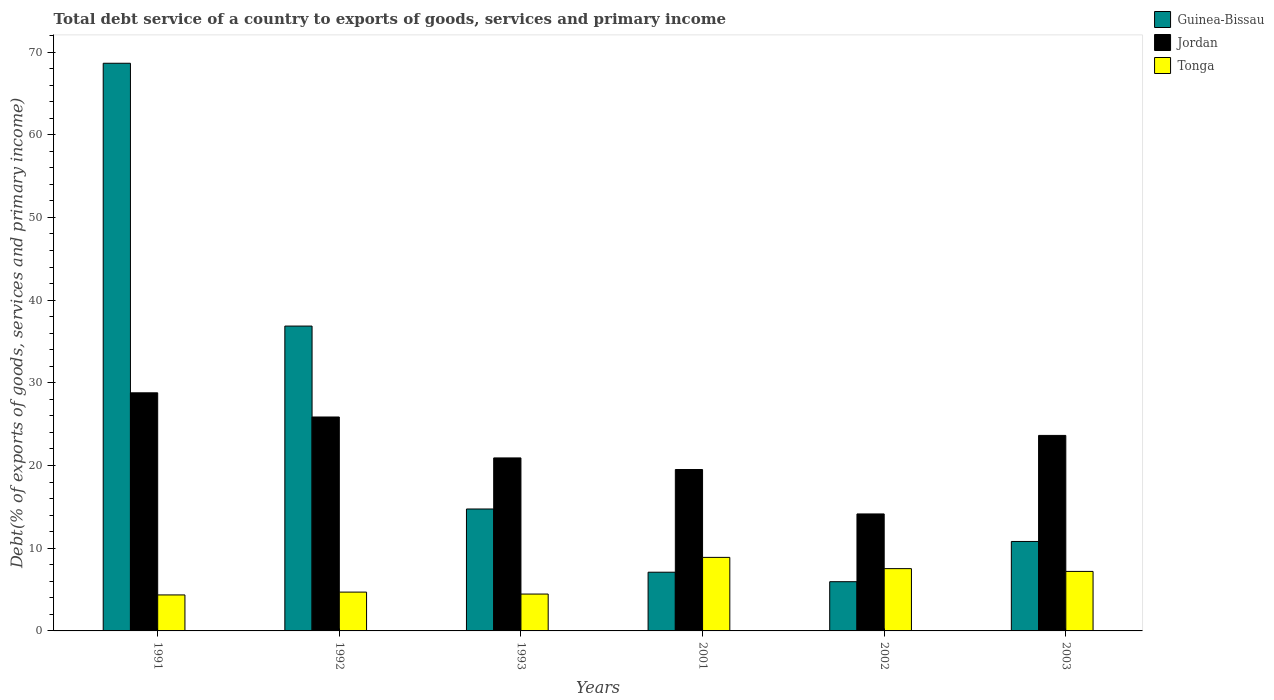Are the number of bars on each tick of the X-axis equal?
Make the answer very short. Yes. In how many cases, is the number of bars for a given year not equal to the number of legend labels?
Offer a terse response. 0. What is the total debt service in Tonga in 2001?
Offer a terse response. 8.89. Across all years, what is the maximum total debt service in Tonga?
Your response must be concise. 8.89. Across all years, what is the minimum total debt service in Guinea-Bissau?
Your answer should be very brief. 5.95. In which year was the total debt service in Guinea-Bissau minimum?
Your response must be concise. 2002. What is the total total debt service in Guinea-Bissau in the graph?
Give a very brief answer. 144.11. What is the difference between the total debt service in Tonga in 1991 and that in 2002?
Your response must be concise. -3.18. What is the difference between the total debt service in Tonga in 2003 and the total debt service in Jordan in 2002?
Your answer should be very brief. -6.95. What is the average total debt service in Jordan per year?
Give a very brief answer. 22.15. In the year 1993, what is the difference between the total debt service in Guinea-Bissau and total debt service in Tonga?
Make the answer very short. 10.28. In how many years, is the total debt service in Guinea-Bissau greater than 36 %?
Make the answer very short. 2. What is the ratio of the total debt service in Tonga in 1992 to that in 1993?
Give a very brief answer. 1.05. Is the total debt service in Tonga in 1993 less than that in 2002?
Give a very brief answer. Yes. What is the difference between the highest and the second highest total debt service in Guinea-Bissau?
Offer a very short reply. 31.78. What is the difference between the highest and the lowest total debt service in Tonga?
Your answer should be compact. 4.54. What does the 3rd bar from the left in 2001 represents?
Your answer should be very brief. Tonga. What does the 3rd bar from the right in 2001 represents?
Make the answer very short. Guinea-Bissau. How many bars are there?
Your answer should be compact. 18. How many years are there in the graph?
Make the answer very short. 6. Are the values on the major ticks of Y-axis written in scientific E-notation?
Provide a succinct answer. No. Does the graph contain any zero values?
Offer a terse response. No. Where does the legend appear in the graph?
Your answer should be very brief. Top right. How many legend labels are there?
Keep it short and to the point. 3. How are the legend labels stacked?
Offer a terse response. Vertical. What is the title of the graph?
Give a very brief answer. Total debt service of a country to exports of goods, services and primary income. What is the label or title of the Y-axis?
Your answer should be compact. Debt(% of exports of goods, services and primary income). What is the Debt(% of exports of goods, services and primary income) in Guinea-Bissau in 1991?
Keep it short and to the point. 68.64. What is the Debt(% of exports of goods, services and primary income) in Jordan in 1991?
Offer a terse response. 28.79. What is the Debt(% of exports of goods, services and primary income) of Tonga in 1991?
Keep it short and to the point. 4.35. What is the Debt(% of exports of goods, services and primary income) in Guinea-Bissau in 1992?
Give a very brief answer. 36.86. What is the Debt(% of exports of goods, services and primary income) in Jordan in 1992?
Ensure brevity in your answer.  25.87. What is the Debt(% of exports of goods, services and primary income) in Tonga in 1992?
Ensure brevity in your answer.  4.69. What is the Debt(% of exports of goods, services and primary income) in Guinea-Bissau in 1993?
Ensure brevity in your answer.  14.74. What is the Debt(% of exports of goods, services and primary income) of Jordan in 1993?
Give a very brief answer. 20.92. What is the Debt(% of exports of goods, services and primary income) in Tonga in 1993?
Give a very brief answer. 4.46. What is the Debt(% of exports of goods, services and primary income) of Guinea-Bissau in 2001?
Your answer should be compact. 7.1. What is the Debt(% of exports of goods, services and primary income) of Jordan in 2001?
Provide a succinct answer. 19.52. What is the Debt(% of exports of goods, services and primary income) of Tonga in 2001?
Provide a succinct answer. 8.89. What is the Debt(% of exports of goods, services and primary income) of Guinea-Bissau in 2002?
Ensure brevity in your answer.  5.95. What is the Debt(% of exports of goods, services and primary income) in Jordan in 2002?
Ensure brevity in your answer.  14.14. What is the Debt(% of exports of goods, services and primary income) in Tonga in 2002?
Provide a short and direct response. 7.53. What is the Debt(% of exports of goods, services and primary income) in Guinea-Bissau in 2003?
Offer a terse response. 10.82. What is the Debt(% of exports of goods, services and primary income) in Jordan in 2003?
Keep it short and to the point. 23.64. What is the Debt(% of exports of goods, services and primary income) in Tonga in 2003?
Offer a very short reply. 7.2. Across all years, what is the maximum Debt(% of exports of goods, services and primary income) of Guinea-Bissau?
Offer a very short reply. 68.64. Across all years, what is the maximum Debt(% of exports of goods, services and primary income) in Jordan?
Provide a short and direct response. 28.79. Across all years, what is the maximum Debt(% of exports of goods, services and primary income) in Tonga?
Your response must be concise. 8.89. Across all years, what is the minimum Debt(% of exports of goods, services and primary income) of Guinea-Bissau?
Offer a very short reply. 5.95. Across all years, what is the minimum Debt(% of exports of goods, services and primary income) in Jordan?
Your answer should be very brief. 14.14. Across all years, what is the minimum Debt(% of exports of goods, services and primary income) in Tonga?
Keep it short and to the point. 4.35. What is the total Debt(% of exports of goods, services and primary income) of Guinea-Bissau in the graph?
Keep it short and to the point. 144.11. What is the total Debt(% of exports of goods, services and primary income) of Jordan in the graph?
Your answer should be very brief. 132.87. What is the total Debt(% of exports of goods, services and primary income) in Tonga in the graph?
Provide a short and direct response. 37.12. What is the difference between the Debt(% of exports of goods, services and primary income) in Guinea-Bissau in 1991 and that in 1992?
Your answer should be compact. 31.78. What is the difference between the Debt(% of exports of goods, services and primary income) in Jordan in 1991 and that in 1992?
Your answer should be compact. 2.92. What is the difference between the Debt(% of exports of goods, services and primary income) of Tonga in 1991 and that in 1992?
Offer a terse response. -0.34. What is the difference between the Debt(% of exports of goods, services and primary income) in Guinea-Bissau in 1991 and that in 1993?
Make the answer very short. 53.9. What is the difference between the Debt(% of exports of goods, services and primary income) of Jordan in 1991 and that in 1993?
Your answer should be compact. 7.87. What is the difference between the Debt(% of exports of goods, services and primary income) of Tonga in 1991 and that in 1993?
Provide a succinct answer. -0.11. What is the difference between the Debt(% of exports of goods, services and primary income) of Guinea-Bissau in 1991 and that in 2001?
Make the answer very short. 61.54. What is the difference between the Debt(% of exports of goods, services and primary income) in Jordan in 1991 and that in 2001?
Provide a short and direct response. 9.28. What is the difference between the Debt(% of exports of goods, services and primary income) in Tonga in 1991 and that in 2001?
Make the answer very short. -4.54. What is the difference between the Debt(% of exports of goods, services and primary income) in Guinea-Bissau in 1991 and that in 2002?
Offer a very short reply. 62.69. What is the difference between the Debt(% of exports of goods, services and primary income) in Jordan in 1991 and that in 2002?
Keep it short and to the point. 14.65. What is the difference between the Debt(% of exports of goods, services and primary income) of Tonga in 1991 and that in 2002?
Make the answer very short. -3.18. What is the difference between the Debt(% of exports of goods, services and primary income) of Guinea-Bissau in 1991 and that in 2003?
Offer a terse response. 57.82. What is the difference between the Debt(% of exports of goods, services and primary income) in Jordan in 1991 and that in 2003?
Ensure brevity in your answer.  5.15. What is the difference between the Debt(% of exports of goods, services and primary income) of Tonga in 1991 and that in 2003?
Your answer should be very brief. -2.84. What is the difference between the Debt(% of exports of goods, services and primary income) of Guinea-Bissau in 1992 and that in 1993?
Provide a succinct answer. 22.12. What is the difference between the Debt(% of exports of goods, services and primary income) of Jordan in 1992 and that in 1993?
Offer a terse response. 4.95. What is the difference between the Debt(% of exports of goods, services and primary income) in Tonga in 1992 and that in 1993?
Offer a very short reply. 0.24. What is the difference between the Debt(% of exports of goods, services and primary income) in Guinea-Bissau in 1992 and that in 2001?
Provide a short and direct response. 29.76. What is the difference between the Debt(% of exports of goods, services and primary income) of Jordan in 1992 and that in 2001?
Give a very brief answer. 6.35. What is the difference between the Debt(% of exports of goods, services and primary income) in Tonga in 1992 and that in 2001?
Keep it short and to the point. -4.2. What is the difference between the Debt(% of exports of goods, services and primary income) in Guinea-Bissau in 1992 and that in 2002?
Give a very brief answer. 30.91. What is the difference between the Debt(% of exports of goods, services and primary income) in Jordan in 1992 and that in 2002?
Keep it short and to the point. 11.72. What is the difference between the Debt(% of exports of goods, services and primary income) in Tonga in 1992 and that in 2002?
Keep it short and to the point. -2.84. What is the difference between the Debt(% of exports of goods, services and primary income) of Guinea-Bissau in 1992 and that in 2003?
Your answer should be very brief. 26.04. What is the difference between the Debt(% of exports of goods, services and primary income) in Jordan in 1992 and that in 2003?
Offer a very short reply. 2.23. What is the difference between the Debt(% of exports of goods, services and primary income) in Tonga in 1992 and that in 2003?
Offer a terse response. -2.5. What is the difference between the Debt(% of exports of goods, services and primary income) in Guinea-Bissau in 1993 and that in 2001?
Give a very brief answer. 7.64. What is the difference between the Debt(% of exports of goods, services and primary income) in Jordan in 1993 and that in 2001?
Your answer should be compact. 1.4. What is the difference between the Debt(% of exports of goods, services and primary income) in Tonga in 1993 and that in 2001?
Provide a short and direct response. -4.43. What is the difference between the Debt(% of exports of goods, services and primary income) in Guinea-Bissau in 1993 and that in 2002?
Your answer should be very brief. 8.79. What is the difference between the Debt(% of exports of goods, services and primary income) of Jordan in 1993 and that in 2002?
Your answer should be very brief. 6.77. What is the difference between the Debt(% of exports of goods, services and primary income) of Tonga in 1993 and that in 2002?
Offer a very short reply. -3.07. What is the difference between the Debt(% of exports of goods, services and primary income) in Guinea-Bissau in 1993 and that in 2003?
Your response must be concise. 3.93. What is the difference between the Debt(% of exports of goods, services and primary income) in Jordan in 1993 and that in 2003?
Your answer should be compact. -2.72. What is the difference between the Debt(% of exports of goods, services and primary income) in Tonga in 1993 and that in 2003?
Provide a short and direct response. -2.74. What is the difference between the Debt(% of exports of goods, services and primary income) in Guinea-Bissau in 2001 and that in 2002?
Offer a very short reply. 1.15. What is the difference between the Debt(% of exports of goods, services and primary income) of Jordan in 2001 and that in 2002?
Your answer should be very brief. 5.37. What is the difference between the Debt(% of exports of goods, services and primary income) in Tonga in 2001 and that in 2002?
Make the answer very short. 1.36. What is the difference between the Debt(% of exports of goods, services and primary income) of Guinea-Bissau in 2001 and that in 2003?
Your answer should be compact. -3.72. What is the difference between the Debt(% of exports of goods, services and primary income) in Jordan in 2001 and that in 2003?
Provide a succinct answer. -4.12. What is the difference between the Debt(% of exports of goods, services and primary income) of Tonga in 2001 and that in 2003?
Provide a short and direct response. 1.7. What is the difference between the Debt(% of exports of goods, services and primary income) in Guinea-Bissau in 2002 and that in 2003?
Your answer should be very brief. -4.86. What is the difference between the Debt(% of exports of goods, services and primary income) in Jordan in 2002 and that in 2003?
Ensure brevity in your answer.  -9.49. What is the difference between the Debt(% of exports of goods, services and primary income) of Tonga in 2002 and that in 2003?
Your answer should be very brief. 0.33. What is the difference between the Debt(% of exports of goods, services and primary income) of Guinea-Bissau in 1991 and the Debt(% of exports of goods, services and primary income) of Jordan in 1992?
Ensure brevity in your answer.  42.77. What is the difference between the Debt(% of exports of goods, services and primary income) in Guinea-Bissau in 1991 and the Debt(% of exports of goods, services and primary income) in Tonga in 1992?
Offer a terse response. 63.94. What is the difference between the Debt(% of exports of goods, services and primary income) in Jordan in 1991 and the Debt(% of exports of goods, services and primary income) in Tonga in 1992?
Your answer should be very brief. 24.1. What is the difference between the Debt(% of exports of goods, services and primary income) in Guinea-Bissau in 1991 and the Debt(% of exports of goods, services and primary income) in Jordan in 1993?
Ensure brevity in your answer.  47.72. What is the difference between the Debt(% of exports of goods, services and primary income) of Guinea-Bissau in 1991 and the Debt(% of exports of goods, services and primary income) of Tonga in 1993?
Make the answer very short. 64.18. What is the difference between the Debt(% of exports of goods, services and primary income) in Jordan in 1991 and the Debt(% of exports of goods, services and primary income) in Tonga in 1993?
Provide a short and direct response. 24.33. What is the difference between the Debt(% of exports of goods, services and primary income) of Guinea-Bissau in 1991 and the Debt(% of exports of goods, services and primary income) of Jordan in 2001?
Keep it short and to the point. 49.12. What is the difference between the Debt(% of exports of goods, services and primary income) of Guinea-Bissau in 1991 and the Debt(% of exports of goods, services and primary income) of Tonga in 2001?
Ensure brevity in your answer.  59.75. What is the difference between the Debt(% of exports of goods, services and primary income) of Jordan in 1991 and the Debt(% of exports of goods, services and primary income) of Tonga in 2001?
Your answer should be compact. 19.9. What is the difference between the Debt(% of exports of goods, services and primary income) of Guinea-Bissau in 1991 and the Debt(% of exports of goods, services and primary income) of Jordan in 2002?
Offer a very short reply. 54.49. What is the difference between the Debt(% of exports of goods, services and primary income) of Guinea-Bissau in 1991 and the Debt(% of exports of goods, services and primary income) of Tonga in 2002?
Offer a very short reply. 61.11. What is the difference between the Debt(% of exports of goods, services and primary income) of Jordan in 1991 and the Debt(% of exports of goods, services and primary income) of Tonga in 2002?
Ensure brevity in your answer.  21.26. What is the difference between the Debt(% of exports of goods, services and primary income) of Guinea-Bissau in 1991 and the Debt(% of exports of goods, services and primary income) of Jordan in 2003?
Provide a succinct answer. 45. What is the difference between the Debt(% of exports of goods, services and primary income) of Guinea-Bissau in 1991 and the Debt(% of exports of goods, services and primary income) of Tonga in 2003?
Your response must be concise. 61.44. What is the difference between the Debt(% of exports of goods, services and primary income) in Jordan in 1991 and the Debt(% of exports of goods, services and primary income) in Tonga in 2003?
Make the answer very short. 21.59. What is the difference between the Debt(% of exports of goods, services and primary income) in Guinea-Bissau in 1992 and the Debt(% of exports of goods, services and primary income) in Jordan in 1993?
Provide a succinct answer. 15.94. What is the difference between the Debt(% of exports of goods, services and primary income) of Guinea-Bissau in 1992 and the Debt(% of exports of goods, services and primary income) of Tonga in 1993?
Provide a succinct answer. 32.4. What is the difference between the Debt(% of exports of goods, services and primary income) in Jordan in 1992 and the Debt(% of exports of goods, services and primary income) in Tonga in 1993?
Your answer should be very brief. 21.41. What is the difference between the Debt(% of exports of goods, services and primary income) in Guinea-Bissau in 1992 and the Debt(% of exports of goods, services and primary income) in Jordan in 2001?
Give a very brief answer. 17.35. What is the difference between the Debt(% of exports of goods, services and primary income) in Guinea-Bissau in 1992 and the Debt(% of exports of goods, services and primary income) in Tonga in 2001?
Offer a terse response. 27.97. What is the difference between the Debt(% of exports of goods, services and primary income) in Jordan in 1992 and the Debt(% of exports of goods, services and primary income) in Tonga in 2001?
Your answer should be very brief. 16.97. What is the difference between the Debt(% of exports of goods, services and primary income) of Guinea-Bissau in 1992 and the Debt(% of exports of goods, services and primary income) of Jordan in 2002?
Offer a very short reply. 22.72. What is the difference between the Debt(% of exports of goods, services and primary income) in Guinea-Bissau in 1992 and the Debt(% of exports of goods, services and primary income) in Tonga in 2002?
Your response must be concise. 29.33. What is the difference between the Debt(% of exports of goods, services and primary income) in Jordan in 1992 and the Debt(% of exports of goods, services and primary income) in Tonga in 2002?
Make the answer very short. 18.34. What is the difference between the Debt(% of exports of goods, services and primary income) in Guinea-Bissau in 1992 and the Debt(% of exports of goods, services and primary income) in Jordan in 2003?
Offer a very short reply. 13.22. What is the difference between the Debt(% of exports of goods, services and primary income) in Guinea-Bissau in 1992 and the Debt(% of exports of goods, services and primary income) in Tonga in 2003?
Your answer should be compact. 29.66. What is the difference between the Debt(% of exports of goods, services and primary income) of Jordan in 1992 and the Debt(% of exports of goods, services and primary income) of Tonga in 2003?
Provide a succinct answer. 18.67. What is the difference between the Debt(% of exports of goods, services and primary income) in Guinea-Bissau in 1993 and the Debt(% of exports of goods, services and primary income) in Jordan in 2001?
Provide a short and direct response. -4.77. What is the difference between the Debt(% of exports of goods, services and primary income) of Guinea-Bissau in 1993 and the Debt(% of exports of goods, services and primary income) of Tonga in 2001?
Provide a succinct answer. 5.85. What is the difference between the Debt(% of exports of goods, services and primary income) in Jordan in 1993 and the Debt(% of exports of goods, services and primary income) in Tonga in 2001?
Give a very brief answer. 12.03. What is the difference between the Debt(% of exports of goods, services and primary income) in Guinea-Bissau in 1993 and the Debt(% of exports of goods, services and primary income) in Jordan in 2002?
Keep it short and to the point. 0.6. What is the difference between the Debt(% of exports of goods, services and primary income) in Guinea-Bissau in 1993 and the Debt(% of exports of goods, services and primary income) in Tonga in 2002?
Offer a very short reply. 7.21. What is the difference between the Debt(% of exports of goods, services and primary income) in Jordan in 1993 and the Debt(% of exports of goods, services and primary income) in Tonga in 2002?
Offer a terse response. 13.39. What is the difference between the Debt(% of exports of goods, services and primary income) of Guinea-Bissau in 1993 and the Debt(% of exports of goods, services and primary income) of Jordan in 2003?
Make the answer very short. -8.9. What is the difference between the Debt(% of exports of goods, services and primary income) in Guinea-Bissau in 1993 and the Debt(% of exports of goods, services and primary income) in Tonga in 2003?
Keep it short and to the point. 7.55. What is the difference between the Debt(% of exports of goods, services and primary income) of Jordan in 1993 and the Debt(% of exports of goods, services and primary income) of Tonga in 2003?
Provide a succinct answer. 13.72. What is the difference between the Debt(% of exports of goods, services and primary income) in Guinea-Bissau in 2001 and the Debt(% of exports of goods, services and primary income) in Jordan in 2002?
Your answer should be compact. -7.04. What is the difference between the Debt(% of exports of goods, services and primary income) of Guinea-Bissau in 2001 and the Debt(% of exports of goods, services and primary income) of Tonga in 2002?
Make the answer very short. -0.43. What is the difference between the Debt(% of exports of goods, services and primary income) of Jordan in 2001 and the Debt(% of exports of goods, services and primary income) of Tonga in 2002?
Offer a terse response. 11.98. What is the difference between the Debt(% of exports of goods, services and primary income) of Guinea-Bissau in 2001 and the Debt(% of exports of goods, services and primary income) of Jordan in 2003?
Make the answer very short. -16.54. What is the difference between the Debt(% of exports of goods, services and primary income) in Guinea-Bissau in 2001 and the Debt(% of exports of goods, services and primary income) in Tonga in 2003?
Your response must be concise. -0.1. What is the difference between the Debt(% of exports of goods, services and primary income) of Jordan in 2001 and the Debt(% of exports of goods, services and primary income) of Tonga in 2003?
Provide a short and direct response. 12.32. What is the difference between the Debt(% of exports of goods, services and primary income) of Guinea-Bissau in 2002 and the Debt(% of exports of goods, services and primary income) of Jordan in 2003?
Offer a terse response. -17.69. What is the difference between the Debt(% of exports of goods, services and primary income) in Guinea-Bissau in 2002 and the Debt(% of exports of goods, services and primary income) in Tonga in 2003?
Offer a very short reply. -1.24. What is the difference between the Debt(% of exports of goods, services and primary income) of Jordan in 2002 and the Debt(% of exports of goods, services and primary income) of Tonga in 2003?
Keep it short and to the point. 6.95. What is the average Debt(% of exports of goods, services and primary income) of Guinea-Bissau per year?
Provide a short and direct response. 24.02. What is the average Debt(% of exports of goods, services and primary income) in Jordan per year?
Provide a succinct answer. 22.15. What is the average Debt(% of exports of goods, services and primary income) in Tonga per year?
Make the answer very short. 6.19. In the year 1991, what is the difference between the Debt(% of exports of goods, services and primary income) in Guinea-Bissau and Debt(% of exports of goods, services and primary income) in Jordan?
Keep it short and to the point. 39.85. In the year 1991, what is the difference between the Debt(% of exports of goods, services and primary income) of Guinea-Bissau and Debt(% of exports of goods, services and primary income) of Tonga?
Your answer should be compact. 64.29. In the year 1991, what is the difference between the Debt(% of exports of goods, services and primary income) of Jordan and Debt(% of exports of goods, services and primary income) of Tonga?
Give a very brief answer. 24.44. In the year 1992, what is the difference between the Debt(% of exports of goods, services and primary income) in Guinea-Bissau and Debt(% of exports of goods, services and primary income) in Jordan?
Ensure brevity in your answer.  10.99. In the year 1992, what is the difference between the Debt(% of exports of goods, services and primary income) of Guinea-Bissau and Debt(% of exports of goods, services and primary income) of Tonga?
Give a very brief answer. 32.17. In the year 1992, what is the difference between the Debt(% of exports of goods, services and primary income) of Jordan and Debt(% of exports of goods, services and primary income) of Tonga?
Provide a short and direct response. 21.17. In the year 1993, what is the difference between the Debt(% of exports of goods, services and primary income) of Guinea-Bissau and Debt(% of exports of goods, services and primary income) of Jordan?
Your response must be concise. -6.17. In the year 1993, what is the difference between the Debt(% of exports of goods, services and primary income) in Guinea-Bissau and Debt(% of exports of goods, services and primary income) in Tonga?
Make the answer very short. 10.29. In the year 1993, what is the difference between the Debt(% of exports of goods, services and primary income) in Jordan and Debt(% of exports of goods, services and primary income) in Tonga?
Give a very brief answer. 16.46. In the year 2001, what is the difference between the Debt(% of exports of goods, services and primary income) in Guinea-Bissau and Debt(% of exports of goods, services and primary income) in Jordan?
Keep it short and to the point. -12.42. In the year 2001, what is the difference between the Debt(% of exports of goods, services and primary income) in Guinea-Bissau and Debt(% of exports of goods, services and primary income) in Tonga?
Keep it short and to the point. -1.79. In the year 2001, what is the difference between the Debt(% of exports of goods, services and primary income) in Jordan and Debt(% of exports of goods, services and primary income) in Tonga?
Keep it short and to the point. 10.62. In the year 2002, what is the difference between the Debt(% of exports of goods, services and primary income) of Guinea-Bissau and Debt(% of exports of goods, services and primary income) of Jordan?
Ensure brevity in your answer.  -8.19. In the year 2002, what is the difference between the Debt(% of exports of goods, services and primary income) of Guinea-Bissau and Debt(% of exports of goods, services and primary income) of Tonga?
Ensure brevity in your answer.  -1.58. In the year 2002, what is the difference between the Debt(% of exports of goods, services and primary income) of Jordan and Debt(% of exports of goods, services and primary income) of Tonga?
Your answer should be very brief. 6.61. In the year 2003, what is the difference between the Debt(% of exports of goods, services and primary income) of Guinea-Bissau and Debt(% of exports of goods, services and primary income) of Jordan?
Your response must be concise. -12.82. In the year 2003, what is the difference between the Debt(% of exports of goods, services and primary income) of Guinea-Bissau and Debt(% of exports of goods, services and primary income) of Tonga?
Your answer should be very brief. 3.62. In the year 2003, what is the difference between the Debt(% of exports of goods, services and primary income) in Jordan and Debt(% of exports of goods, services and primary income) in Tonga?
Offer a terse response. 16.44. What is the ratio of the Debt(% of exports of goods, services and primary income) in Guinea-Bissau in 1991 to that in 1992?
Your answer should be very brief. 1.86. What is the ratio of the Debt(% of exports of goods, services and primary income) in Jordan in 1991 to that in 1992?
Your response must be concise. 1.11. What is the ratio of the Debt(% of exports of goods, services and primary income) in Tonga in 1991 to that in 1992?
Your answer should be very brief. 0.93. What is the ratio of the Debt(% of exports of goods, services and primary income) of Guinea-Bissau in 1991 to that in 1993?
Your answer should be compact. 4.66. What is the ratio of the Debt(% of exports of goods, services and primary income) in Jordan in 1991 to that in 1993?
Offer a very short reply. 1.38. What is the ratio of the Debt(% of exports of goods, services and primary income) in Guinea-Bissau in 1991 to that in 2001?
Your response must be concise. 9.67. What is the ratio of the Debt(% of exports of goods, services and primary income) of Jordan in 1991 to that in 2001?
Give a very brief answer. 1.48. What is the ratio of the Debt(% of exports of goods, services and primary income) in Tonga in 1991 to that in 2001?
Ensure brevity in your answer.  0.49. What is the ratio of the Debt(% of exports of goods, services and primary income) of Guinea-Bissau in 1991 to that in 2002?
Provide a short and direct response. 11.53. What is the ratio of the Debt(% of exports of goods, services and primary income) of Jordan in 1991 to that in 2002?
Your answer should be very brief. 2.04. What is the ratio of the Debt(% of exports of goods, services and primary income) in Tonga in 1991 to that in 2002?
Provide a short and direct response. 0.58. What is the ratio of the Debt(% of exports of goods, services and primary income) in Guinea-Bissau in 1991 to that in 2003?
Your response must be concise. 6.35. What is the ratio of the Debt(% of exports of goods, services and primary income) in Jordan in 1991 to that in 2003?
Offer a terse response. 1.22. What is the ratio of the Debt(% of exports of goods, services and primary income) in Tonga in 1991 to that in 2003?
Your answer should be compact. 0.6. What is the ratio of the Debt(% of exports of goods, services and primary income) of Guinea-Bissau in 1992 to that in 1993?
Give a very brief answer. 2.5. What is the ratio of the Debt(% of exports of goods, services and primary income) of Jordan in 1992 to that in 1993?
Offer a very short reply. 1.24. What is the ratio of the Debt(% of exports of goods, services and primary income) of Tonga in 1992 to that in 1993?
Ensure brevity in your answer.  1.05. What is the ratio of the Debt(% of exports of goods, services and primary income) of Guinea-Bissau in 1992 to that in 2001?
Ensure brevity in your answer.  5.19. What is the ratio of the Debt(% of exports of goods, services and primary income) in Jordan in 1992 to that in 2001?
Offer a terse response. 1.33. What is the ratio of the Debt(% of exports of goods, services and primary income) in Tonga in 1992 to that in 2001?
Your response must be concise. 0.53. What is the ratio of the Debt(% of exports of goods, services and primary income) of Guinea-Bissau in 1992 to that in 2002?
Your answer should be compact. 6.19. What is the ratio of the Debt(% of exports of goods, services and primary income) of Jordan in 1992 to that in 2002?
Make the answer very short. 1.83. What is the ratio of the Debt(% of exports of goods, services and primary income) of Tonga in 1992 to that in 2002?
Your answer should be very brief. 0.62. What is the ratio of the Debt(% of exports of goods, services and primary income) in Guinea-Bissau in 1992 to that in 2003?
Your response must be concise. 3.41. What is the ratio of the Debt(% of exports of goods, services and primary income) of Jordan in 1992 to that in 2003?
Your response must be concise. 1.09. What is the ratio of the Debt(% of exports of goods, services and primary income) in Tonga in 1992 to that in 2003?
Make the answer very short. 0.65. What is the ratio of the Debt(% of exports of goods, services and primary income) in Guinea-Bissau in 1993 to that in 2001?
Provide a succinct answer. 2.08. What is the ratio of the Debt(% of exports of goods, services and primary income) of Jordan in 1993 to that in 2001?
Your response must be concise. 1.07. What is the ratio of the Debt(% of exports of goods, services and primary income) in Tonga in 1993 to that in 2001?
Give a very brief answer. 0.5. What is the ratio of the Debt(% of exports of goods, services and primary income) of Guinea-Bissau in 1993 to that in 2002?
Ensure brevity in your answer.  2.48. What is the ratio of the Debt(% of exports of goods, services and primary income) in Jordan in 1993 to that in 2002?
Keep it short and to the point. 1.48. What is the ratio of the Debt(% of exports of goods, services and primary income) of Tonga in 1993 to that in 2002?
Provide a succinct answer. 0.59. What is the ratio of the Debt(% of exports of goods, services and primary income) of Guinea-Bissau in 1993 to that in 2003?
Ensure brevity in your answer.  1.36. What is the ratio of the Debt(% of exports of goods, services and primary income) in Jordan in 1993 to that in 2003?
Offer a terse response. 0.88. What is the ratio of the Debt(% of exports of goods, services and primary income) in Tonga in 1993 to that in 2003?
Your answer should be compact. 0.62. What is the ratio of the Debt(% of exports of goods, services and primary income) in Guinea-Bissau in 2001 to that in 2002?
Your response must be concise. 1.19. What is the ratio of the Debt(% of exports of goods, services and primary income) of Jordan in 2001 to that in 2002?
Provide a short and direct response. 1.38. What is the ratio of the Debt(% of exports of goods, services and primary income) in Tonga in 2001 to that in 2002?
Your response must be concise. 1.18. What is the ratio of the Debt(% of exports of goods, services and primary income) of Guinea-Bissau in 2001 to that in 2003?
Provide a short and direct response. 0.66. What is the ratio of the Debt(% of exports of goods, services and primary income) of Jordan in 2001 to that in 2003?
Ensure brevity in your answer.  0.83. What is the ratio of the Debt(% of exports of goods, services and primary income) of Tonga in 2001 to that in 2003?
Provide a succinct answer. 1.24. What is the ratio of the Debt(% of exports of goods, services and primary income) in Guinea-Bissau in 2002 to that in 2003?
Give a very brief answer. 0.55. What is the ratio of the Debt(% of exports of goods, services and primary income) in Jordan in 2002 to that in 2003?
Provide a succinct answer. 0.6. What is the ratio of the Debt(% of exports of goods, services and primary income) of Tonga in 2002 to that in 2003?
Make the answer very short. 1.05. What is the difference between the highest and the second highest Debt(% of exports of goods, services and primary income) of Guinea-Bissau?
Give a very brief answer. 31.78. What is the difference between the highest and the second highest Debt(% of exports of goods, services and primary income) of Jordan?
Your answer should be compact. 2.92. What is the difference between the highest and the second highest Debt(% of exports of goods, services and primary income) of Tonga?
Make the answer very short. 1.36. What is the difference between the highest and the lowest Debt(% of exports of goods, services and primary income) of Guinea-Bissau?
Your answer should be very brief. 62.69. What is the difference between the highest and the lowest Debt(% of exports of goods, services and primary income) in Jordan?
Your response must be concise. 14.65. What is the difference between the highest and the lowest Debt(% of exports of goods, services and primary income) in Tonga?
Provide a succinct answer. 4.54. 